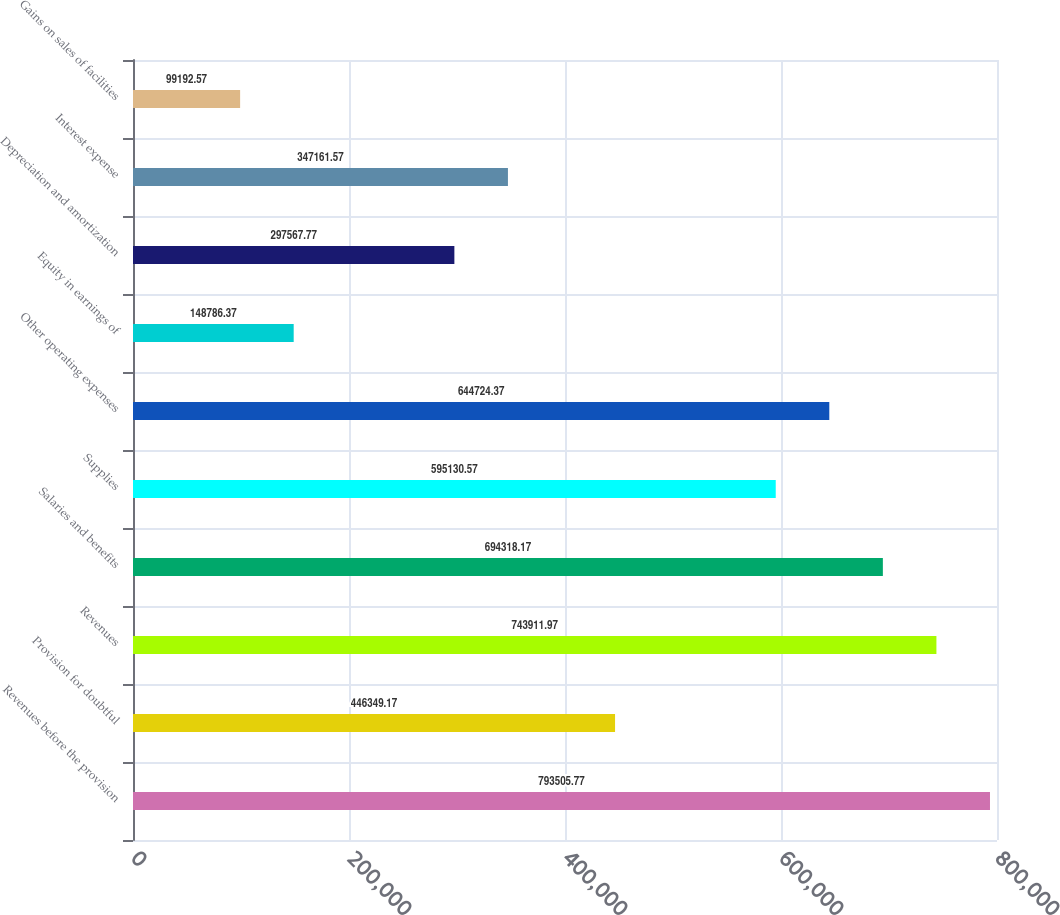Convert chart to OTSL. <chart><loc_0><loc_0><loc_500><loc_500><bar_chart><fcel>Revenues before the provision<fcel>Provision for doubtful<fcel>Revenues<fcel>Salaries and benefits<fcel>Supplies<fcel>Other operating expenses<fcel>Equity in earnings of<fcel>Depreciation and amortization<fcel>Interest expense<fcel>Gains on sales of facilities<nl><fcel>793506<fcel>446349<fcel>743912<fcel>694318<fcel>595131<fcel>644724<fcel>148786<fcel>297568<fcel>347162<fcel>99192.6<nl></chart> 